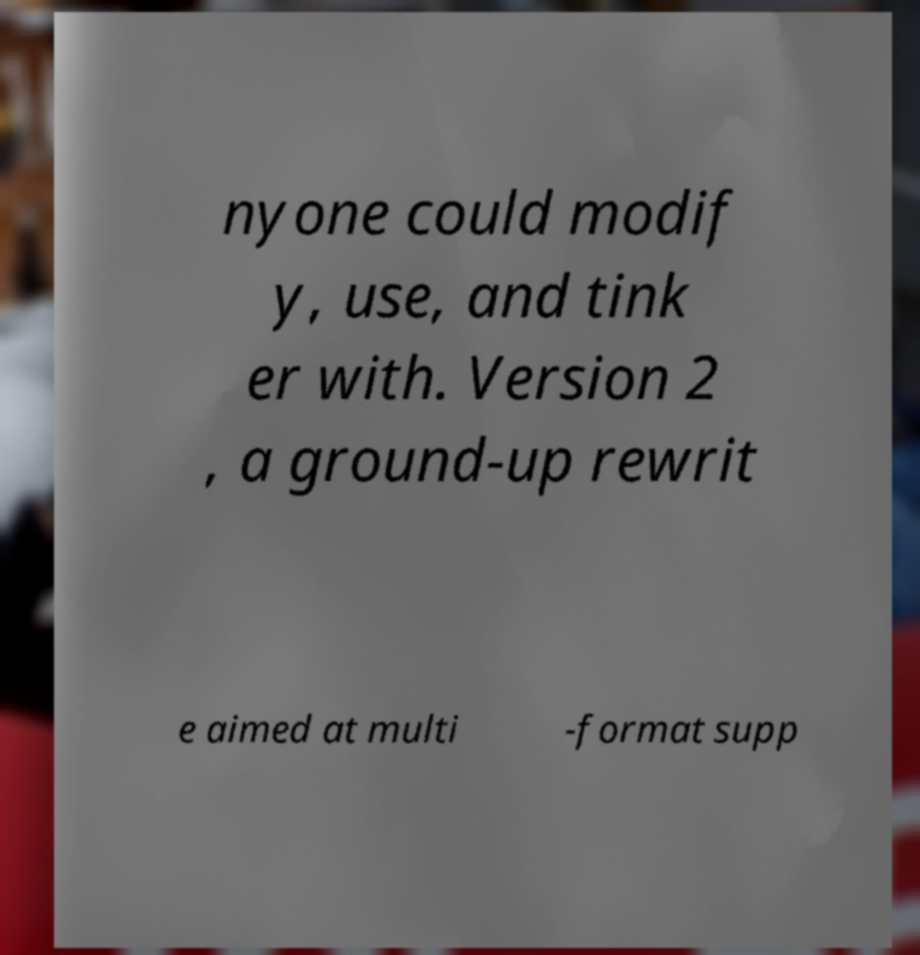Can you read and provide the text displayed in the image?This photo seems to have some interesting text. Can you extract and type it out for me? nyone could modif y, use, and tink er with. Version 2 , a ground-up rewrit e aimed at multi -format supp 